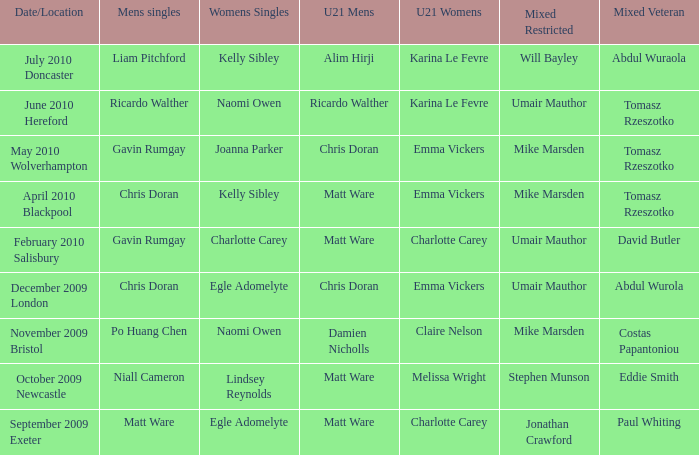When Naomi Owen won the Womens Singles and Ricardo Walther won the Mens Singles, who won the mixed veteran? Tomasz Rzeszotko. 